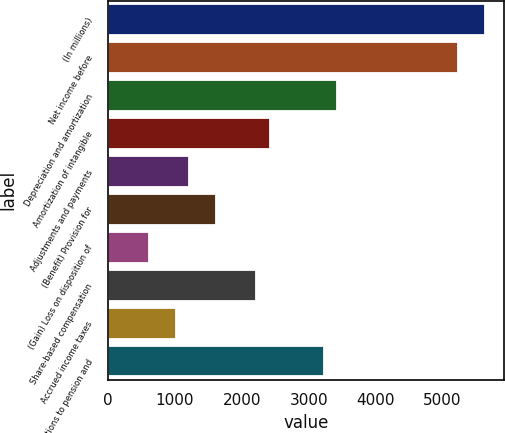Convert chart. <chart><loc_0><loc_0><loc_500><loc_500><bar_chart><fcel>(In millions)<fcel>Net income before<fcel>Depreciation and amortization<fcel>Amortization of intangible<fcel>Adjustments and payments<fcel>(Benefit) Provision for<fcel>(Gain) Loss on disposition of<fcel>Share-based compensation<fcel>Accrued income taxes<fcel>Contributions to pension and<nl><fcel>5641.2<fcel>5238.4<fcel>3425.8<fcel>2418.8<fcel>1210.4<fcel>1613.2<fcel>606.2<fcel>2217.4<fcel>1009<fcel>3224.4<nl></chart> 